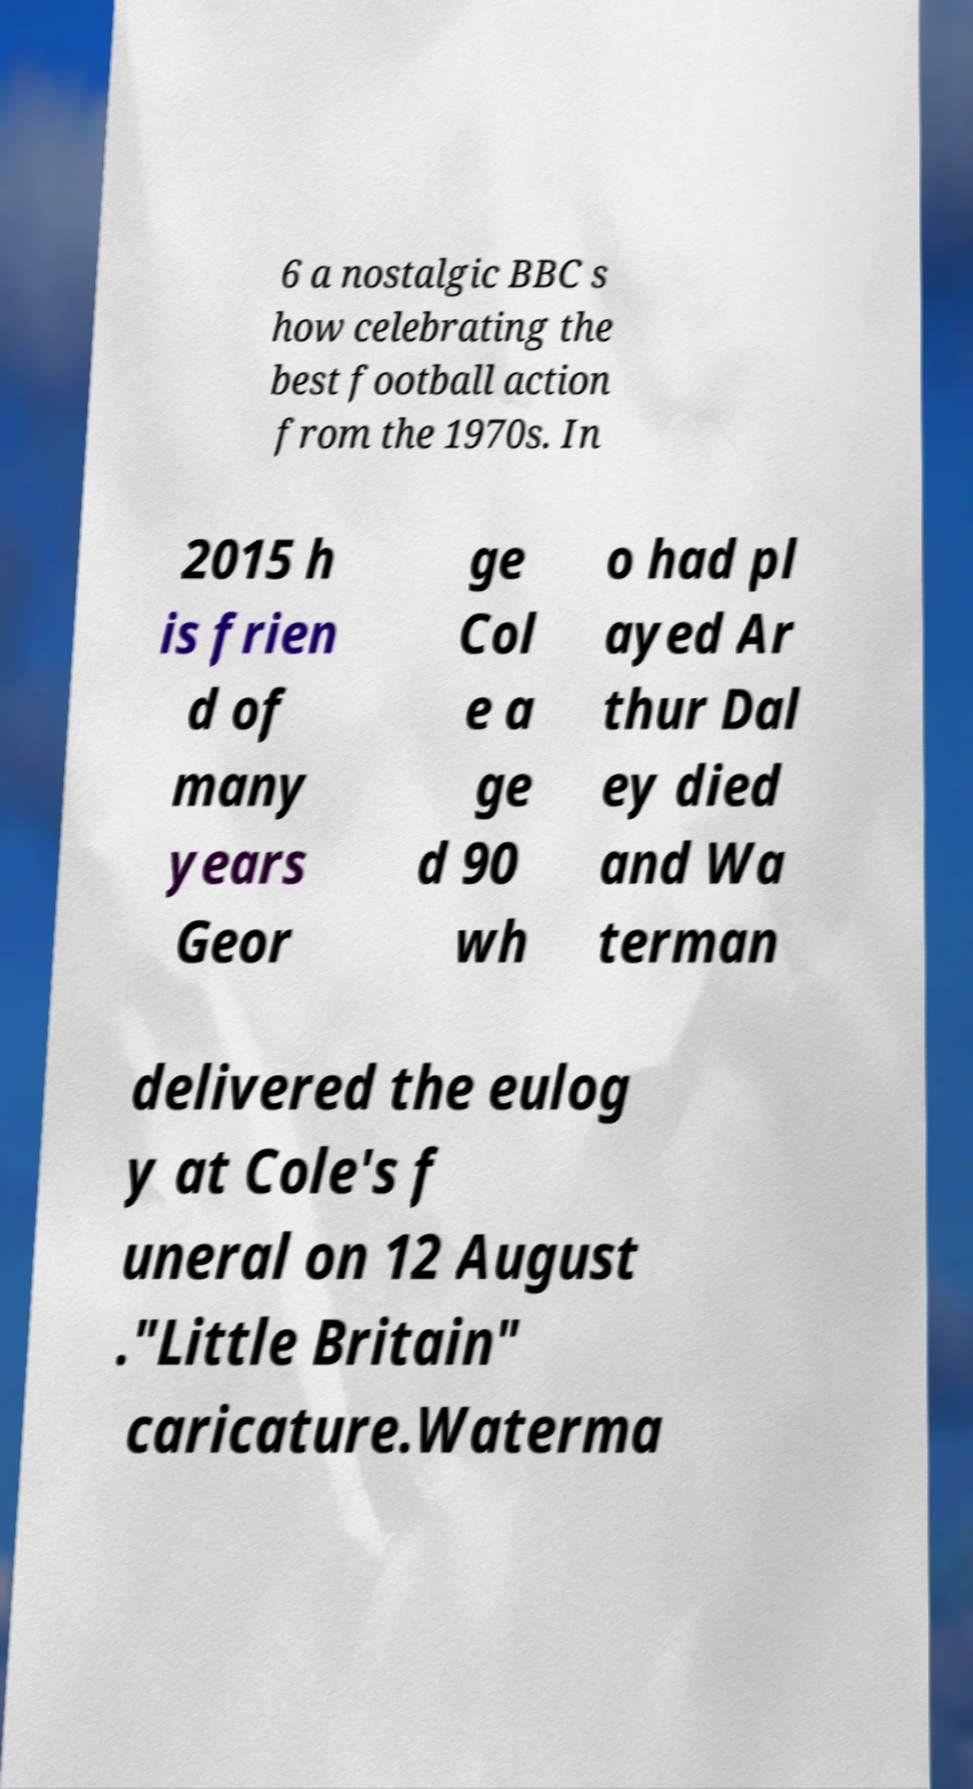Can you accurately transcribe the text from the provided image for me? 6 a nostalgic BBC s how celebrating the best football action from the 1970s. In 2015 h is frien d of many years Geor ge Col e a ge d 90 wh o had pl ayed Ar thur Dal ey died and Wa terman delivered the eulog y at Cole's f uneral on 12 August ."Little Britain" caricature.Waterma 